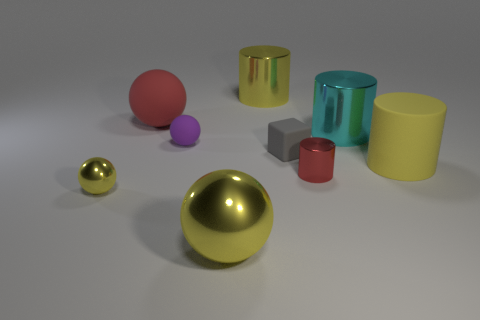Add 1 small balls. How many objects exist? 10 Subtract all spheres. How many objects are left? 5 Subtract 0 yellow cubes. How many objects are left? 9 Subtract all tiny red metal things. Subtract all gray things. How many objects are left? 7 Add 4 red rubber things. How many red rubber things are left? 5 Add 2 red cylinders. How many red cylinders exist? 3 